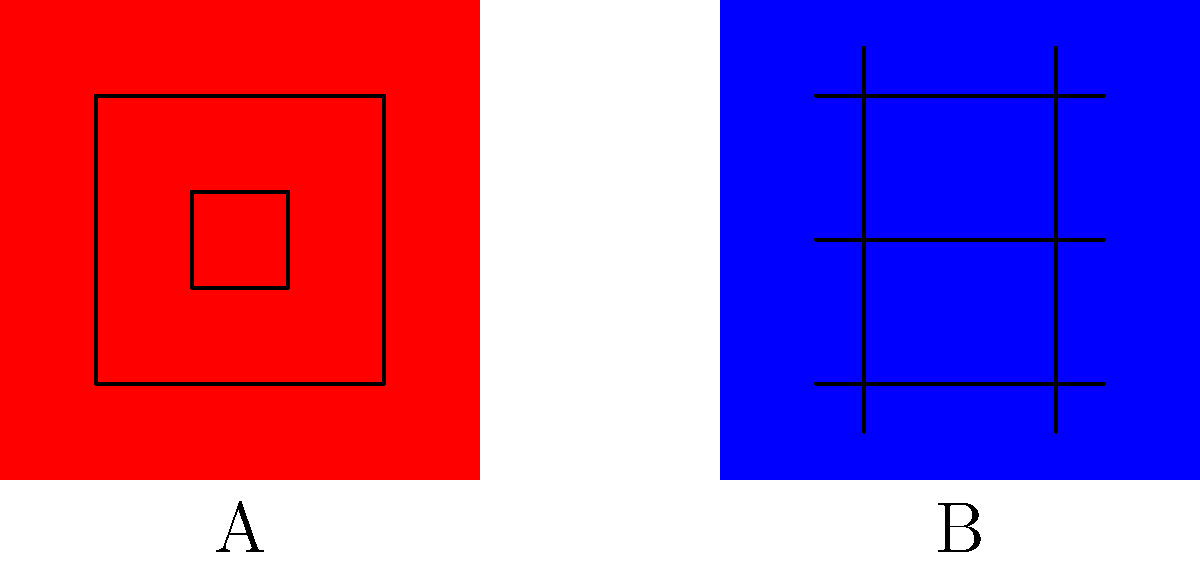Analyze the two artistic styles depicted in the image above. Which style (A or B) is more likely to represent traditional Native Canadian art, and why? To answer this question, we need to examine the characteristics of both styles and compare them to what we know about traditional Native Canadian art:

1. Style A:
   - Uses geometric shapes (squares and rectangles)
   - Employs concentric patterns
   - Utilizes bold, solid colors (red in this case)
   - Features symmetry and balance

2. Style B:
   - Shows a more structured, grid-like pattern
   - Uses straight lines in a repetitive manner
   - Appears more rigid and uniform
   - Resembles European architectural or textile designs

Traditional Native Canadian art often incorporates:
- Geometric shapes and patterns
- Symbolic representations of nature and spirituality
- Bold colors
- Symmetry and balance

Comparing these characteristics:

Style A aligns more closely with traditional Native Canadian art due to its use of geometric shapes, concentric patterns, bold colors, and symmetrical design. These elements are commonly found in various Native Canadian art forms, such as paintings, beadwork, and carved objects.

Style B, on the other hand, displays a more rigid and uniform pattern that is reminiscent of European-influenced designs. This style lacks the organic and symbolic elements typically associated with Native Canadian art.

Therefore, Style A is more likely to represent traditional Native Canadian art.
Answer: Style A 